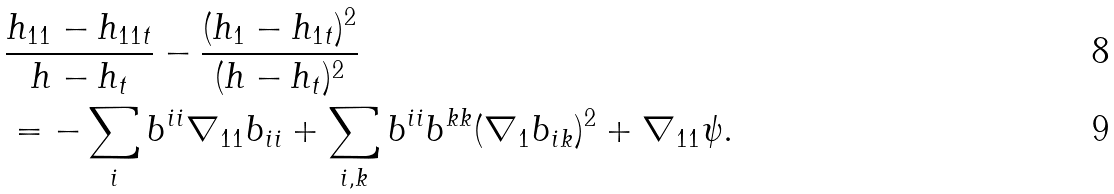Convert formula to latex. <formula><loc_0><loc_0><loc_500><loc_500>& \frac { h _ { 1 1 } - h _ { 1 1 t } } { h - h _ { t } } - \frac { ( h _ { 1 } - h _ { 1 t } ) ^ { 2 } } { ( h - h _ { t } ) ^ { 2 } } \\ & = - \sum _ { i } b ^ { i i } \nabla _ { 1 1 } b _ { i i } + \sum _ { i , k } b ^ { i i } b ^ { k k } ( \nabla _ { 1 } b _ { i k } ) ^ { 2 } + \nabla _ { 1 1 } \psi .</formula> 